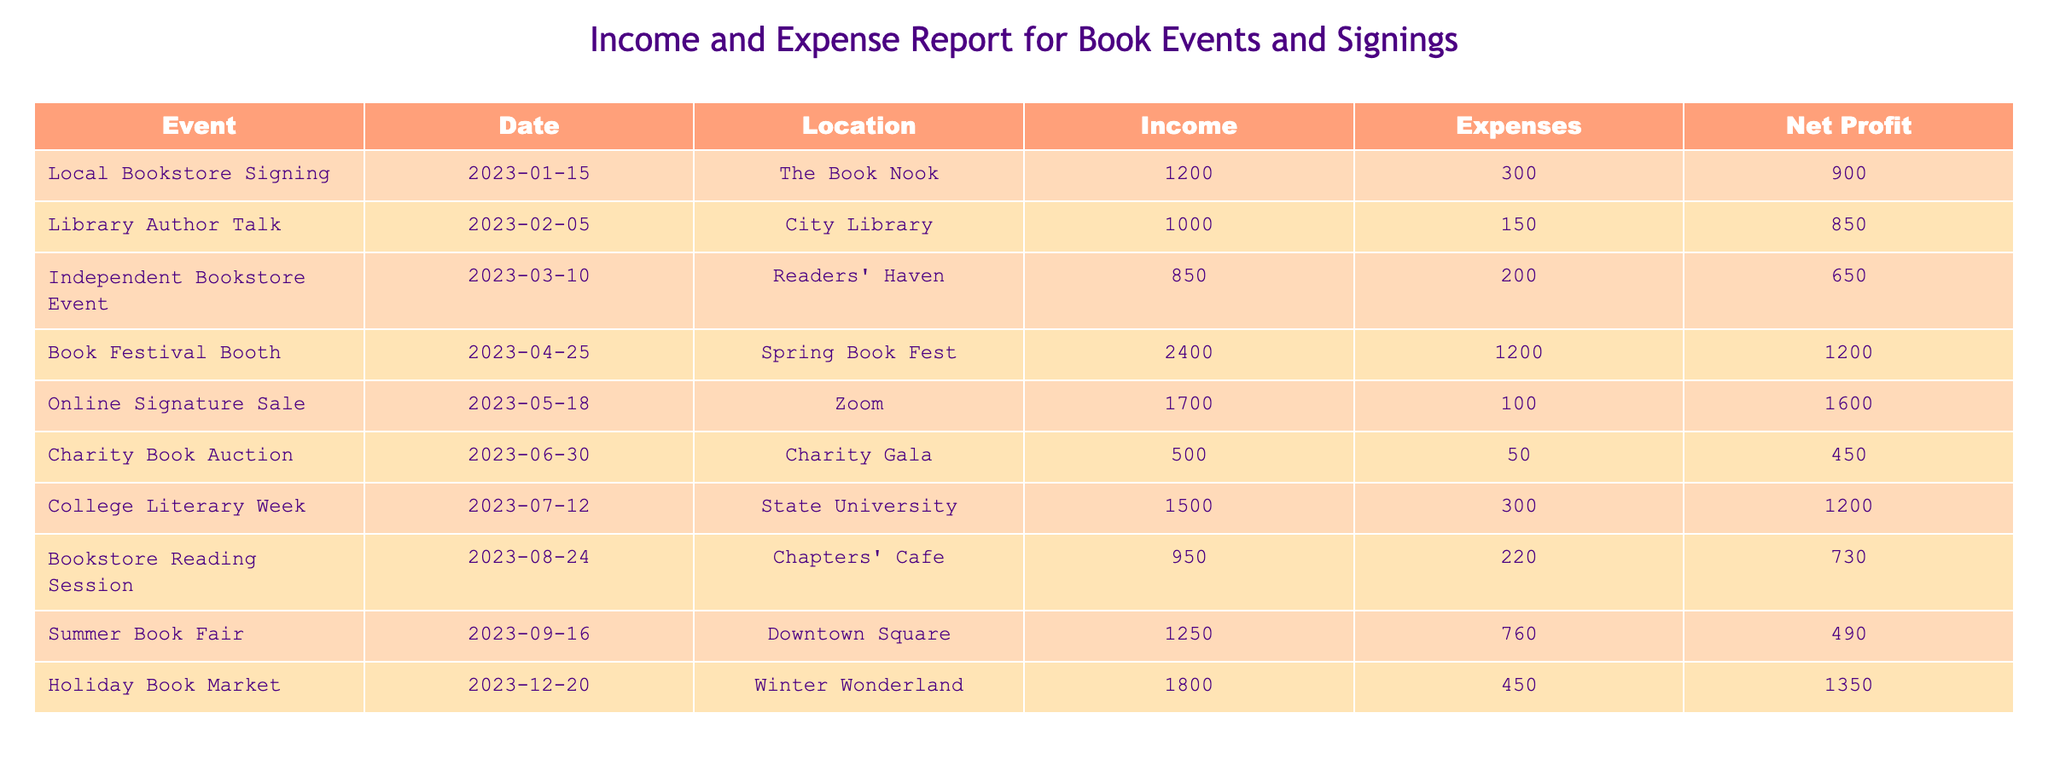What was the highest net profit for an event in 2023? By reviewing the 'Net Profit' column, the highest value can be found. Looking through the values, the highest net profit recorded is 1600 from the 'Online Signature Sale' on May 18, 2023.
Answer: 1600 Which event had the lowest income in 2023? Checking the 'Income' column, 'Independent Bookstore Event' had an income of 850, which is the lowest compared to other events listed.
Answer: 850 Was the expense for the 'Book Festival Booth' greater than the income for the 'Library Author Talk'? The expense for the 'Book Festival Booth' was 1200, while the income for the 'Library Author Talk' was 1000. Since 1200 is greater than 1000, the statement is true.
Answer: Yes What is the total net profit from all events in 2023? To find the total, we sum up all net profits listed: 900 + 850 + 650 + 1200 + 1600 + 450 + 1200 + 730 + 490 + 1350 = 4150.
Answer: 4150 How much more did the 'Holiday Book Market' earn compared to the 'Summer Book Fair'? The net profit for 'Holiday Book Market' is 1350 and for 'Summer Book Fair' is 490. Subtracting 490 from 1350 gives us a difference of 860.
Answer: 860 How many events had a net profit of over 1000? The net profits to consider are: 900, 850, 650, 1200, 1600, 450, 1200, 730, 490, and 1350. The net profits over 1000 are found in: 'Book Festival Booth', 'Online Signature Sale', 'College Literary Week', and 'Holiday Book Market'. This gives us a total of four events with net profits over 1000.
Answer: 4 What was the average income from the events listed? The total income can be calculated by adding all incomes together: 1200 + 1000 + 850 + 2400 + 1700 + 500 + 1500 + 950 + 1250 + 1800 = 10300. There are 10 events, so the average income is 10300/10 = 1030.
Answer: 1030 Did more than half of the events in 2023 have expenses greater than 500? Analyzing the expenses: 300, 150, 200, 1200, 100, 50, 300, 220, 760, 450. The events with expenses above 500 are: 'Book Festival Booth' (1200) and 'Summer Book Fair' (760). There are 10 events total, so only 2 exceed 500 which is less than half.
Answer: No What was the total expense for all events? The total expense adds up all the expenses: 300 + 150 + 200 + 1200 + 100 + 50 + 300 + 220 + 760 + 450 = 2830.
Answer: 2830 